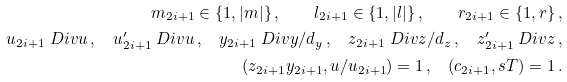<formula> <loc_0><loc_0><loc_500><loc_500>m _ { 2 i + 1 } \in \{ 1 , | m | \} \, , \quad l _ { 2 i + 1 } \in \{ 1 , | l | \} \, , \quad r _ { 2 i + 1 } \in \{ 1 , r \} \, , \\ u _ { 2 i + 1 } \ D i v u \, , \quad u _ { 2 i + 1 } ^ { \prime } \ D i v u \, , \quad y _ { 2 i + 1 } \ D i v y / d _ { y } \, , \quad z _ { 2 i + 1 } \ D i v z / d _ { z } \, , \quad z _ { 2 i + 1 } ^ { \prime } \ D i v z \, , \\ ( z _ { 2 i + 1 } y _ { 2 i + 1 } , u / u _ { 2 i + 1 } ) = 1 \, , \quad ( c _ { 2 i + 1 } , s T ) = 1 \, .</formula> 